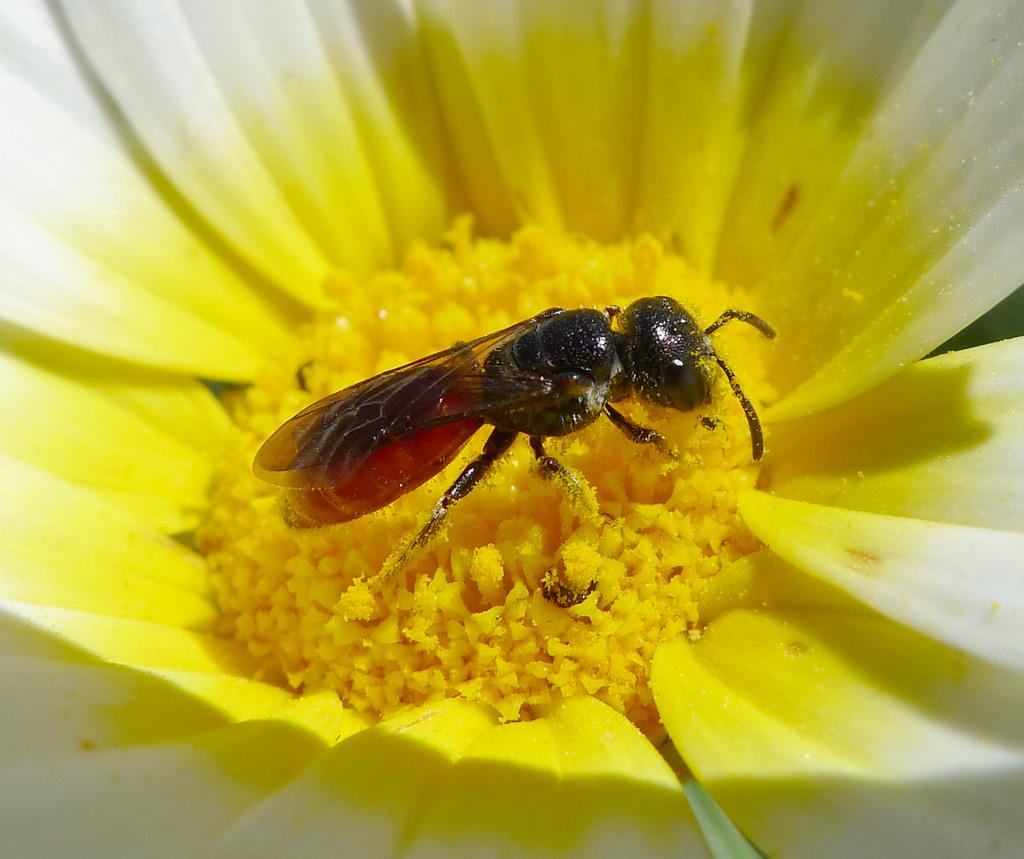What is present on the flower in the image? There is an insect on the flower in the image. Can you describe the flower in the image? The flower has yellow and white colors. What type of wool is being used to make the agreement in the image? There is no wool or agreement present in the image; it features an insect on a flower with yellow and white colors. 